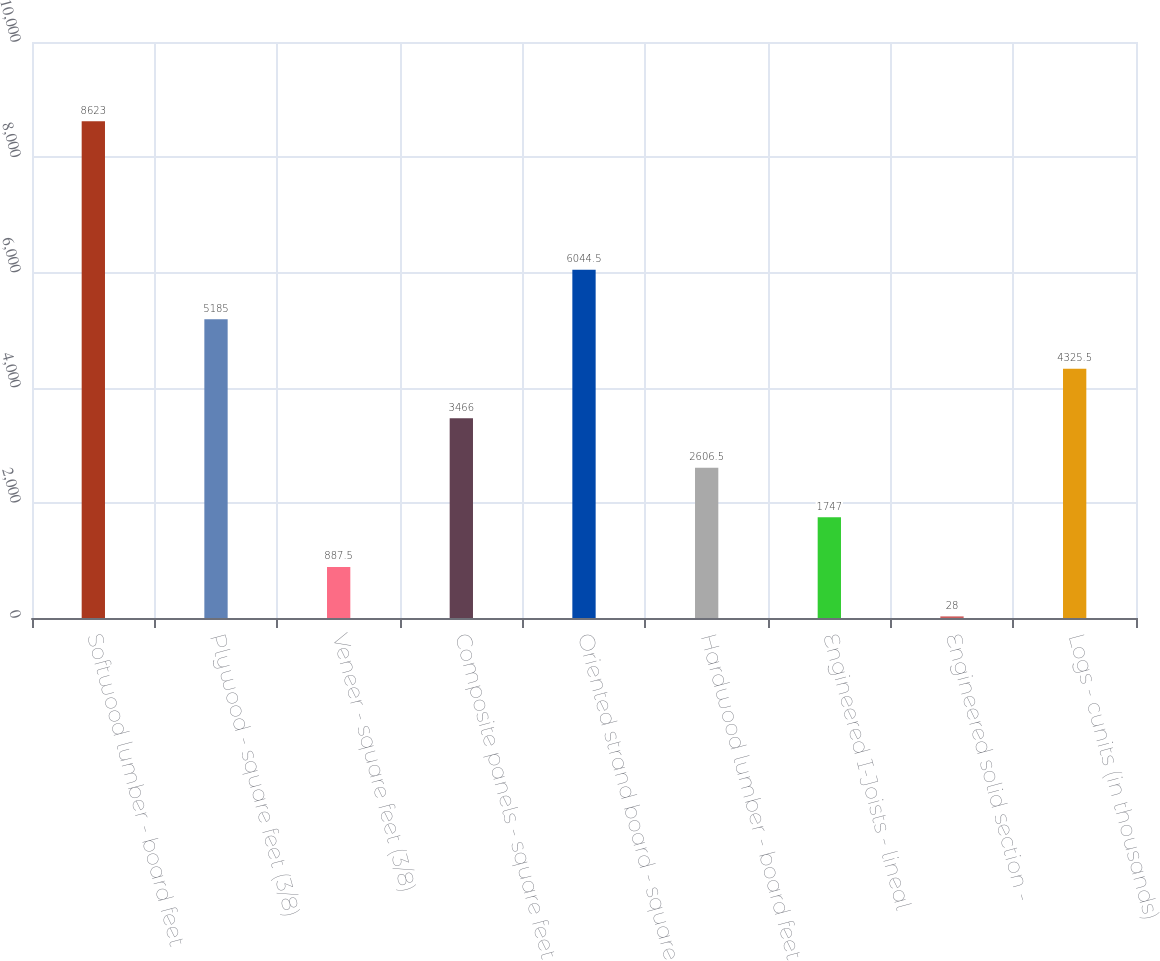Convert chart. <chart><loc_0><loc_0><loc_500><loc_500><bar_chart><fcel>Softwood lumber - board feet<fcel>Plywood - square feet (3/8)<fcel>Veneer - square feet (3/8)<fcel>Composite panels - square feet<fcel>Oriented strand board - square<fcel>Hardwood lumber - board feet<fcel>Engineered I-Joists - lineal<fcel>Engineered solid section -<fcel>Logs - cunits (in thousands)<nl><fcel>8623<fcel>5185<fcel>887.5<fcel>3466<fcel>6044.5<fcel>2606.5<fcel>1747<fcel>28<fcel>4325.5<nl></chart> 